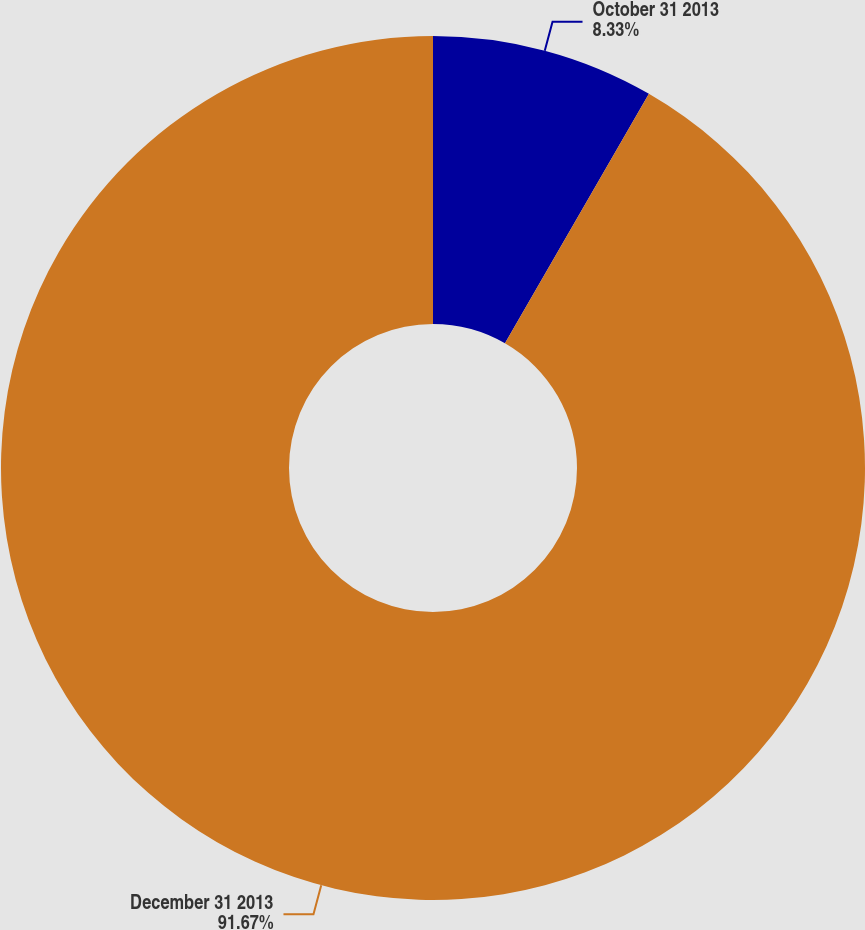Convert chart. <chart><loc_0><loc_0><loc_500><loc_500><pie_chart><fcel>October 31 2013<fcel>December 31 2013<nl><fcel>8.33%<fcel>91.67%<nl></chart> 